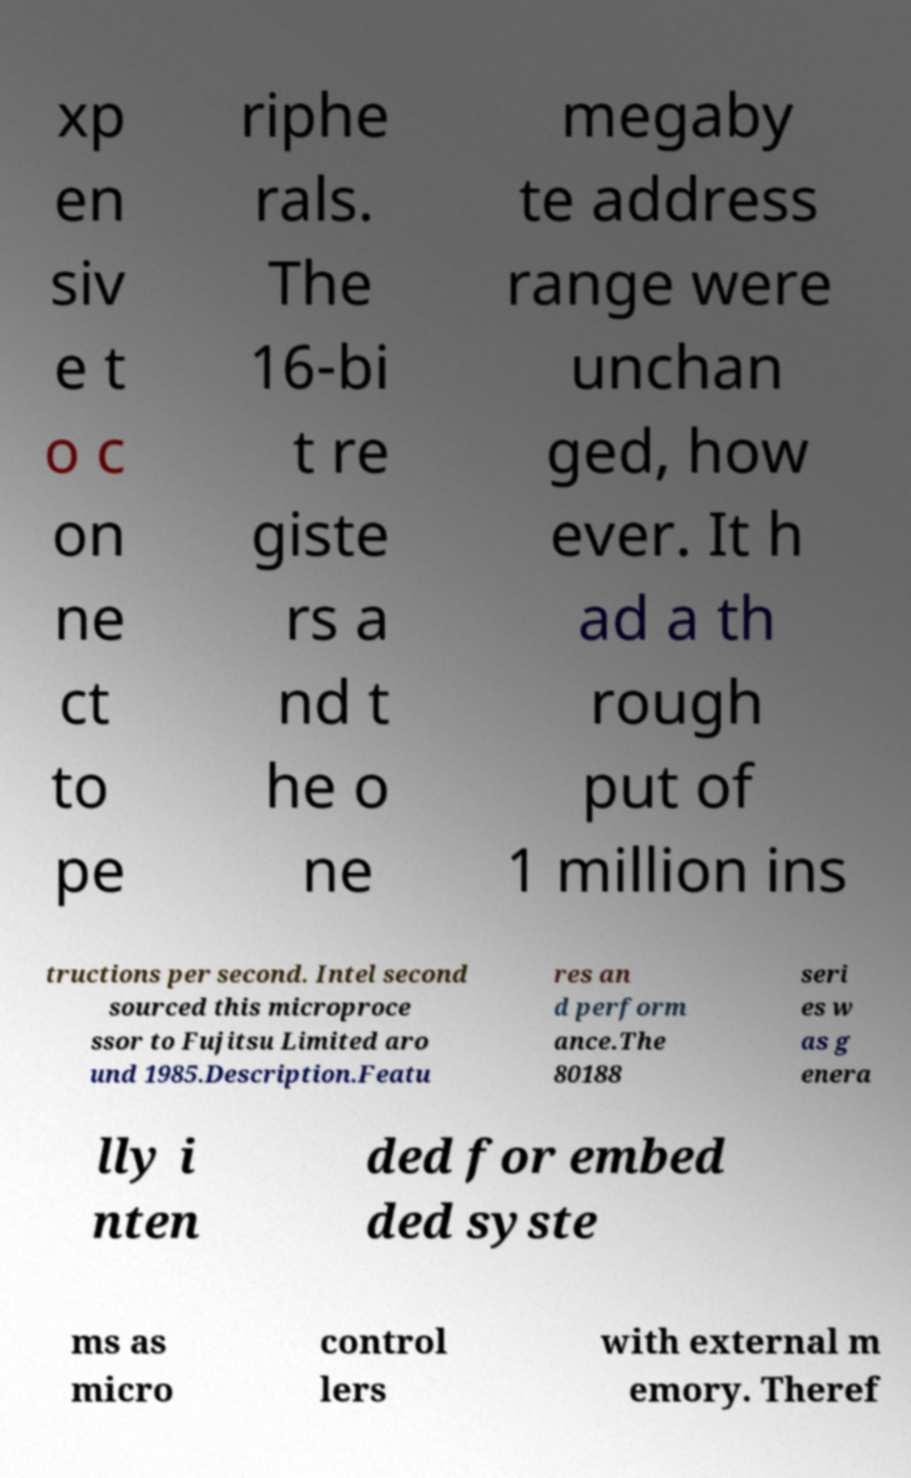There's text embedded in this image that I need extracted. Can you transcribe it verbatim? xp en siv e t o c on ne ct to pe riphe rals. The 16-bi t re giste rs a nd t he o ne megaby te address range were unchan ged, how ever. It h ad a th rough put of 1 million ins tructions per second. Intel second sourced this microproce ssor to Fujitsu Limited aro und 1985.Description.Featu res an d perform ance.The 80188 seri es w as g enera lly i nten ded for embed ded syste ms as micro control lers with external m emory. Theref 